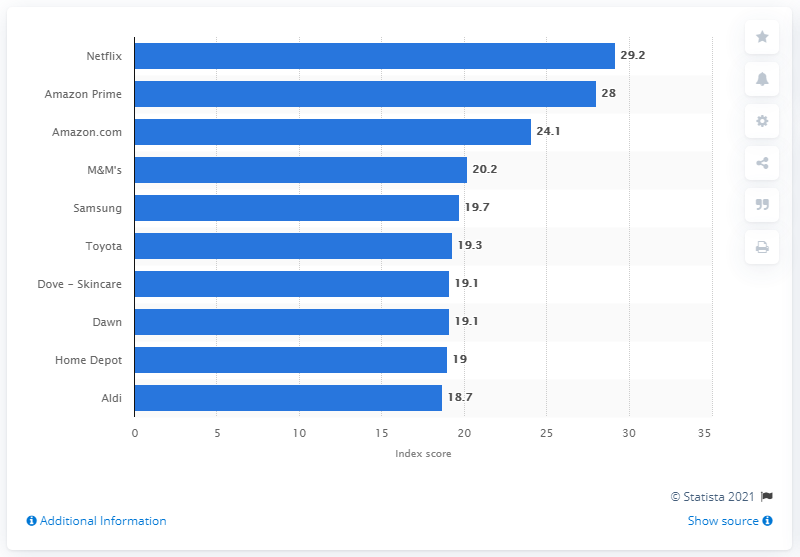Highlight a few significant elements in this photo. In 2019, Netflix's net buzz score was 29.2, indicating a high level of positive attention and discussion surrounding the company and its offerings. Netflix was the highest-ranking brand based on net online buzz. 